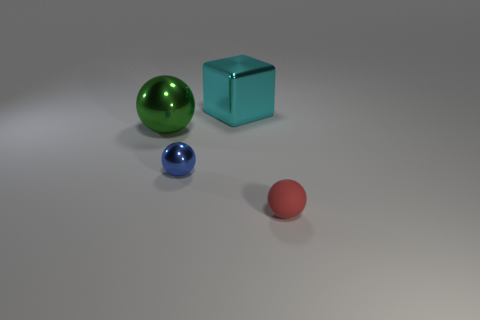Subtract all tiny blue shiny spheres. How many spheres are left? 2 Subtract all blue spheres. How many spheres are left? 2 Subtract 1 spheres. How many spheres are left? 2 Add 3 small red rubber things. How many objects exist? 7 Subtract all gray spheres. Subtract all gray cylinders. How many spheres are left? 3 Subtract all spheres. How many objects are left? 1 Add 2 red rubber balls. How many red rubber balls are left? 3 Add 3 gray shiny cylinders. How many gray shiny cylinders exist? 3 Subtract 0 gray spheres. How many objects are left? 4 Subtract all metal things. Subtract all small red balls. How many objects are left? 0 